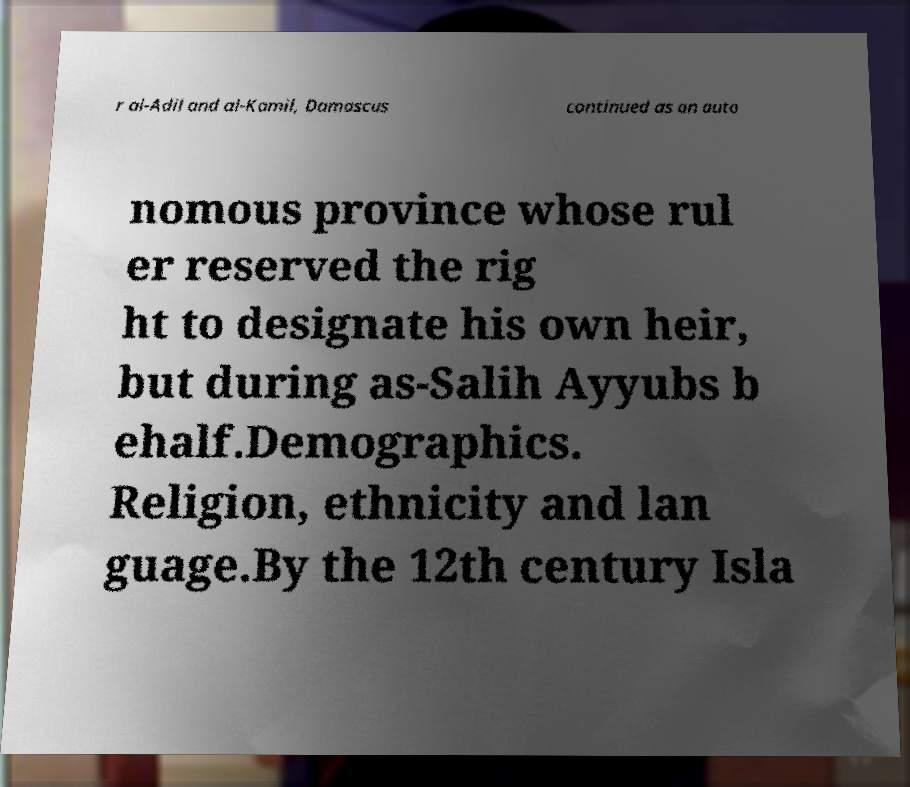For documentation purposes, I need the text within this image transcribed. Could you provide that? r al-Adil and al-Kamil, Damascus continued as an auto nomous province whose rul er reserved the rig ht to designate his own heir, but during as-Salih Ayyubs b ehalf.Demographics. Religion, ethnicity and lan guage.By the 12th century Isla 